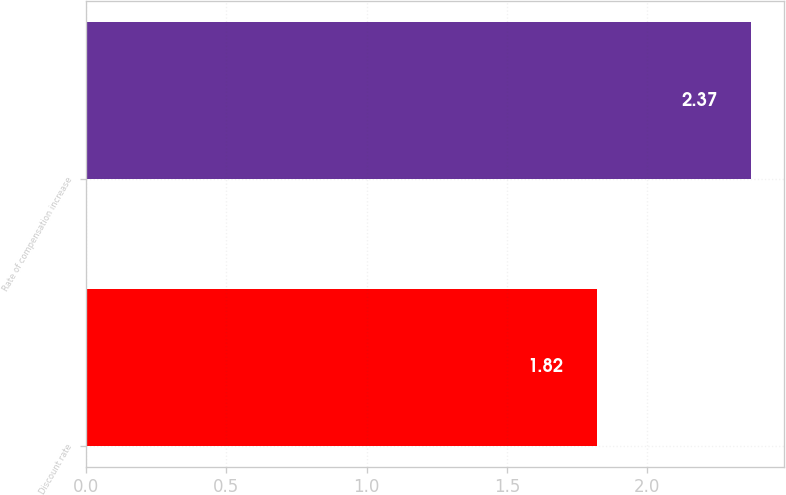<chart> <loc_0><loc_0><loc_500><loc_500><bar_chart><fcel>Discount rate<fcel>Rate of compensation increase<nl><fcel>1.82<fcel>2.37<nl></chart> 